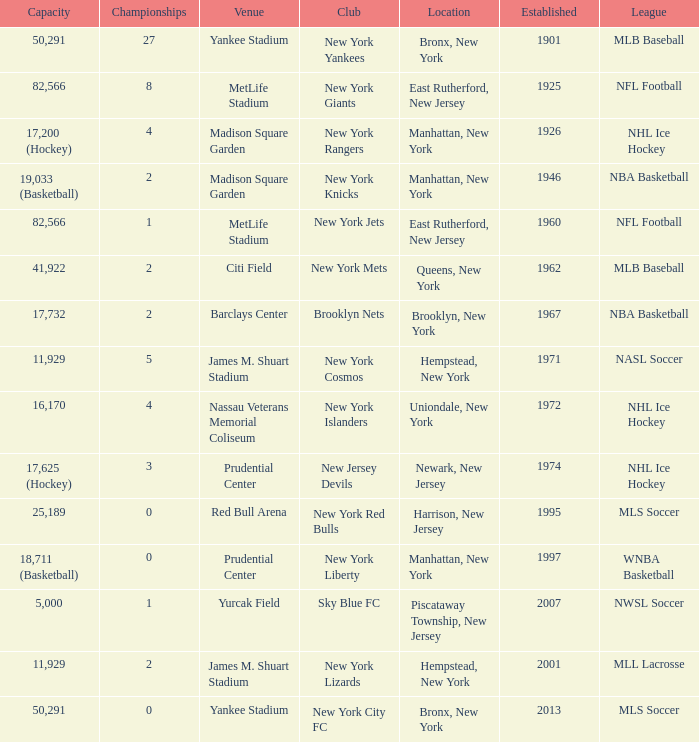When was the venue named nassau veterans memorial coliseum established?? 1972.0. 